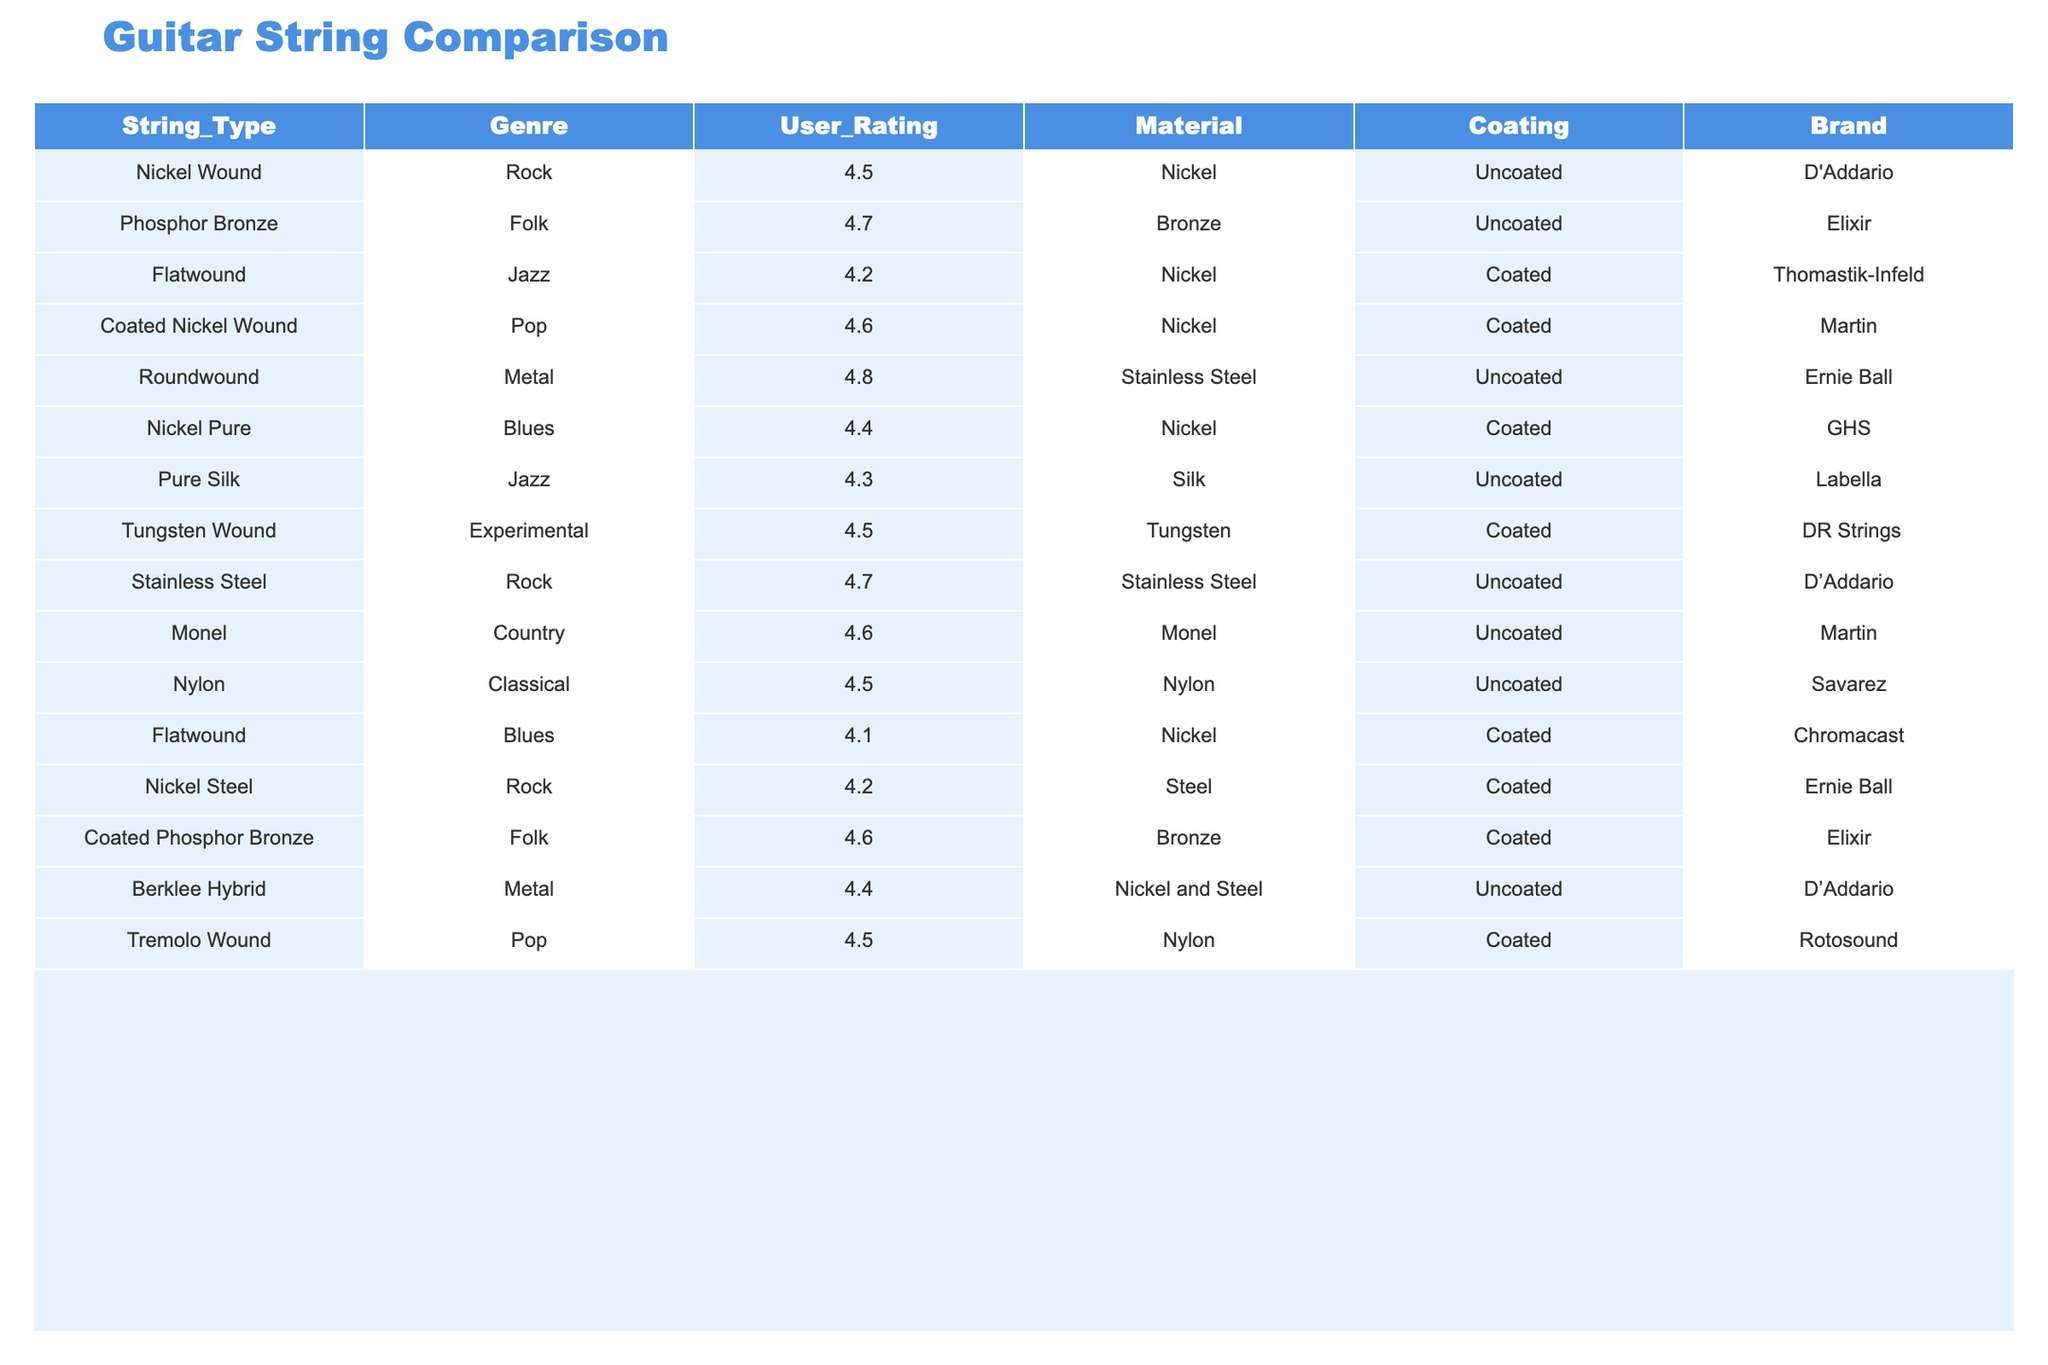What is the user rating of Roundwound strings in the Metal genre? From the table, the entry for Roundwound strings in the Metal genre shows a user rating of 4.8.
Answer: 4.8 Which guitar string type has the highest user rating? Scanning through the ratings in the table, the Roundwound string in the Metal genre has the highest rating of 4.8.
Answer: Roundwound Is there a coated option for Nickel Wound strings? The table shows that Nickel Wound strings are uncoated, therefore there is no coated option for them.
Answer: No What is the difference in user ratings between Flatwound strings in Jazz and Blues genres? The Jazz genre has a user rating of 4.2 for Flatwound strings while the Blues genre has a rating of 4.1. The difference is 4.2 - 4.1 = 0.1.
Answer: 0.1 Which genre has the string with the lowest user rating? Looking at the user ratings, the Flatwound strings in the Blues genre have the lowest rating of 4.1.
Answer: Blues Are all strings in the Rock genre uncoated? By checking the Rock genre entries, Nickel Wound strings are uncoated, while Stainless Steel strings are also uncoated and Nickel Steel is coated. Thus, not all strings in the Rock genre are uncoated.
Answer: No What is the average user rating for strings in the Folk genre? The Folk genre has two entries: Phosphor Bronze rated at 4.7 and Coated Phosphor Bronze rated at 4.6. The average is (4.7 + 4.6) / 2 = 4.65.
Answer: 4.65 Which brand has the most entries in the table? By counting the brands, D'Addario has three entries: Nickel Wound, Stainless Steel, and Berklee Hybrid. No other brand has more than two.
Answer: D'Addario How many different materials are represented in the table? The materials listed are Nickel, Bronze, Stainless Steel, Silk, Tungsten, Monel, Nylon, and Nickel and Steel which totals to eight distinct materials.
Answer: 8 Which guitar string types are coated and what are their user ratings? The coated strings listed are Flatwound (4.2), Nickel Pure (4.4), Coated Nickel Wound (4.6), Coated Phosphor Bronze (4.6), and Tremolo Wound (4.5).
Answer: 4.2, 4.4, 4.6, 4.6, 4.5 